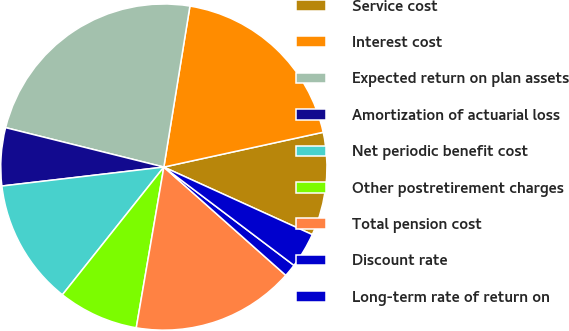<chart> <loc_0><loc_0><loc_500><loc_500><pie_chart><fcel>Service cost<fcel>Interest cost<fcel>Expected return on plan assets<fcel>Amortization of actuarial loss<fcel>Net periodic benefit cost<fcel>Other postretirement charges<fcel>Total pension cost<fcel>Discount rate<fcel>Long-term rate of return on<nl><fcel>10.22%<fcel>19.02%<fcel>23.67%<fcel>5.74%<fcel>12.46%<fcel>7.98%<fcel>16.15%<fcel>1.26%<fcel>3.5%<nl></chart> 